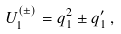Convert formula to latex. <formula><loc_0><loc_0><loc_500><loc_500>U ^ { ( \pm ) } _ { 1 } = q _ { 1 } ^ { 2 } \pm q ^ { \prime } _ { 1 } \, ,</formula> 